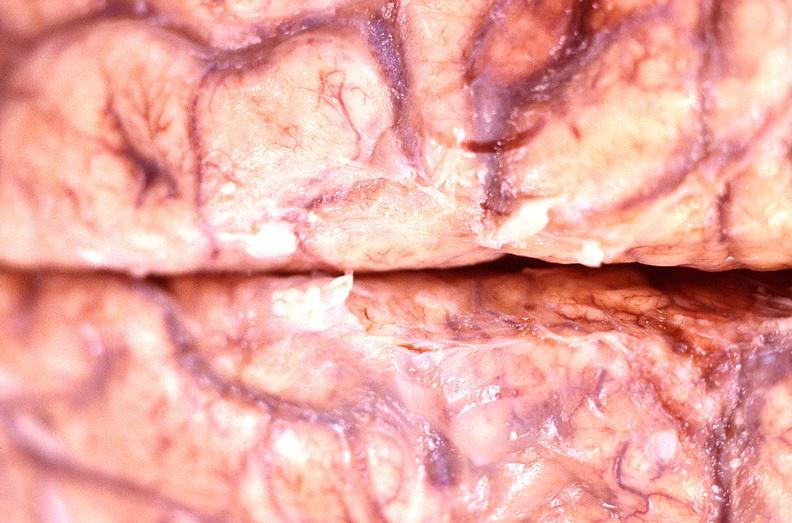what does this image show?
Answer the question using a single word or phrase. Brain abscess 